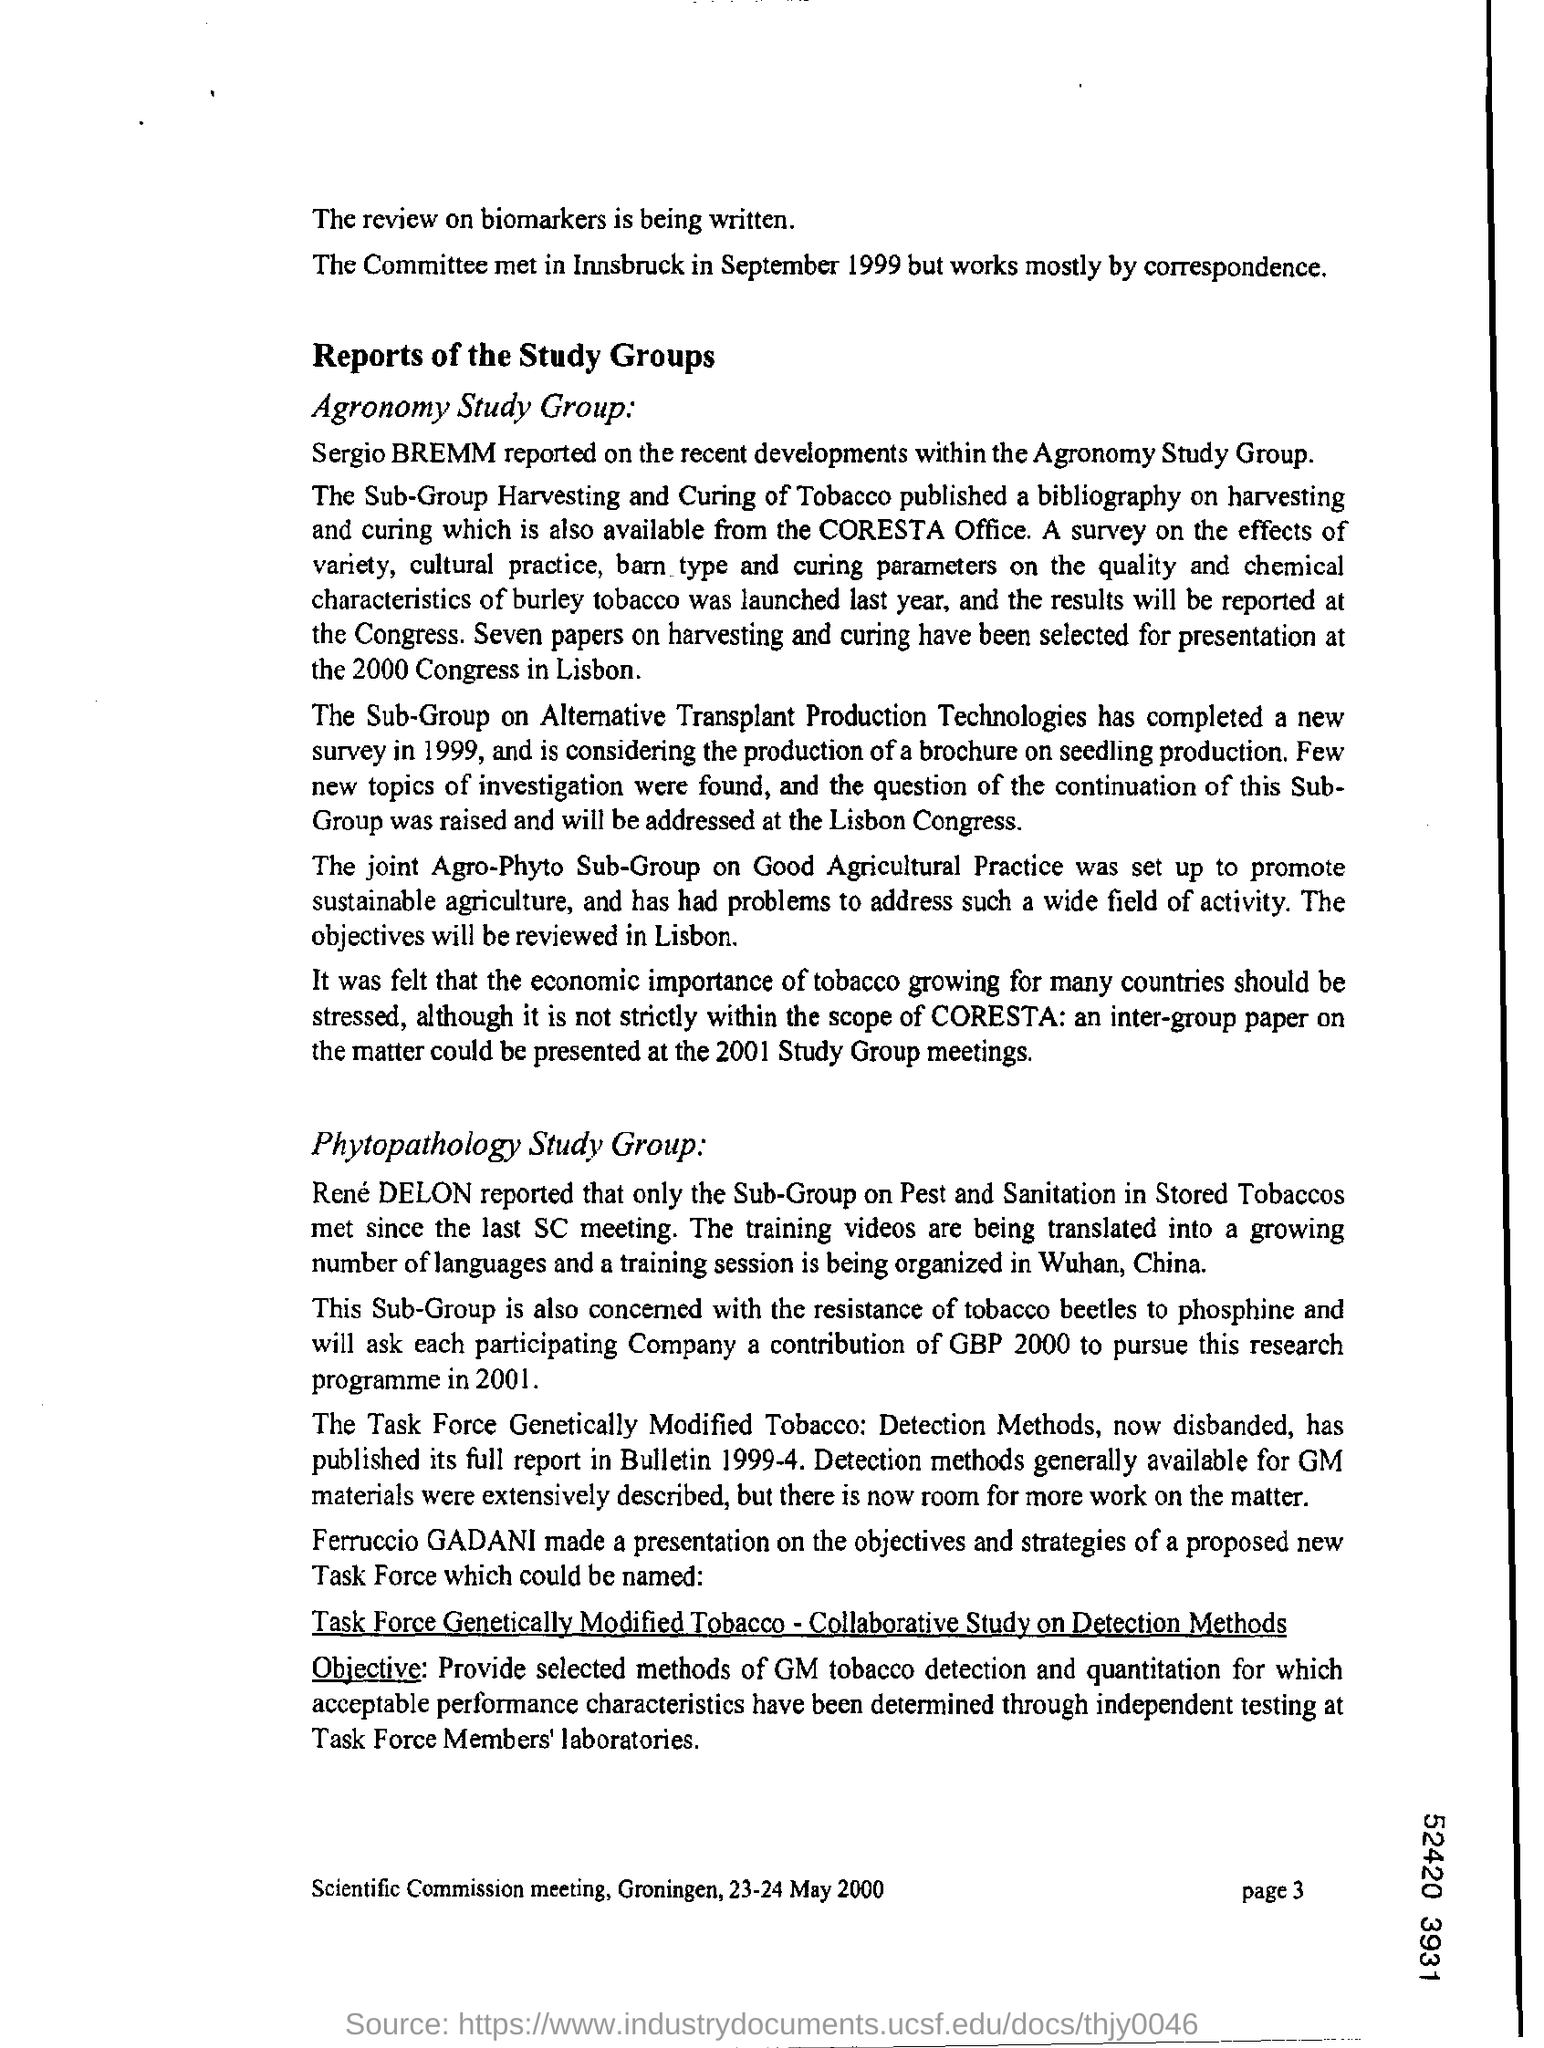Mention the page number at bottom right corner of the page ?
Keep it short and to the point. 3. 